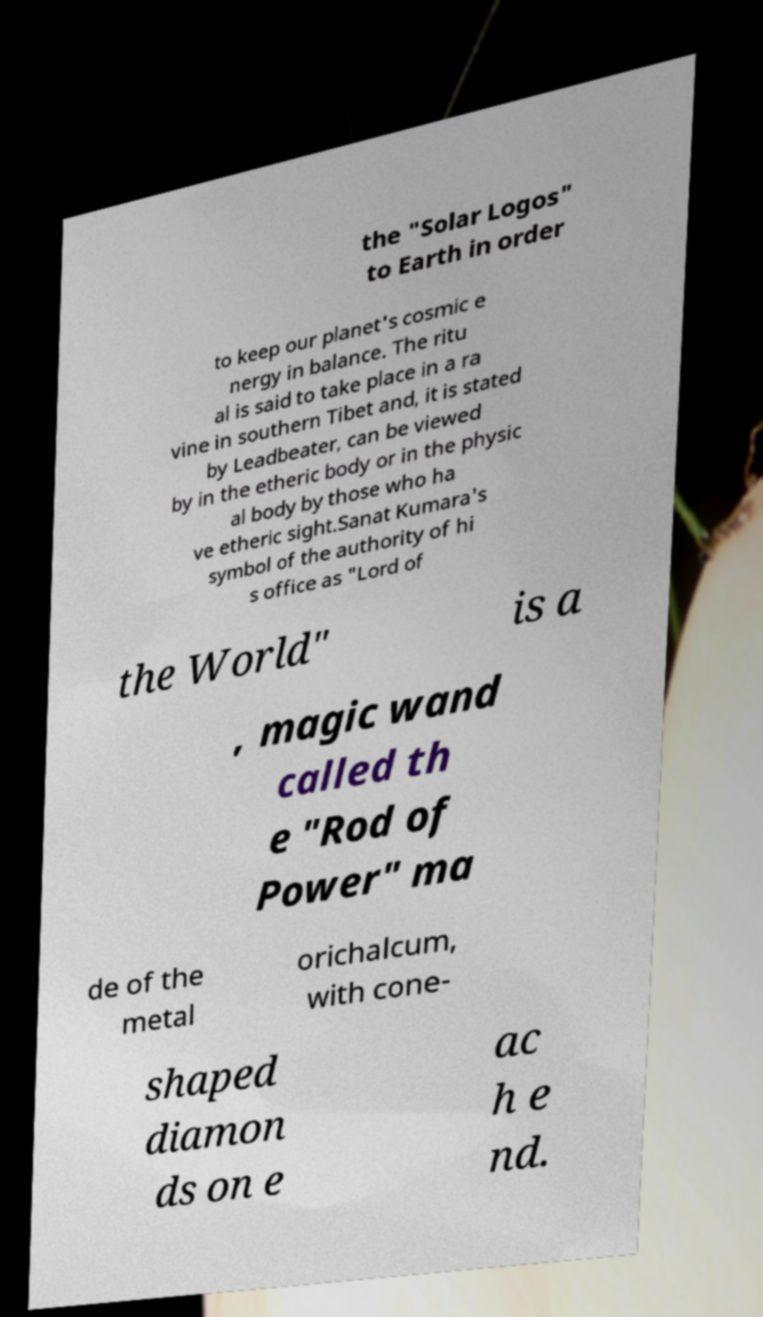I need the written content from this picture converted into text. Can you do that? the "Solar Logos" to Earth in order to keep our planet's cosmic e nergy in balance. The ritu al is said to take place in a ra vine in southern Tibet and, it is stated by Leadbeater, can be viewed by in the etheric body or in the physic al body by those who ha ve etheric sight.Sanat Kumara's symbol of the authority of hi s office as "Lord of the World" is a , magic wand called th e "Rod of Power" ma de of the metal orichalcum, with cone- shaped diamon ds on e ac h e nd. 